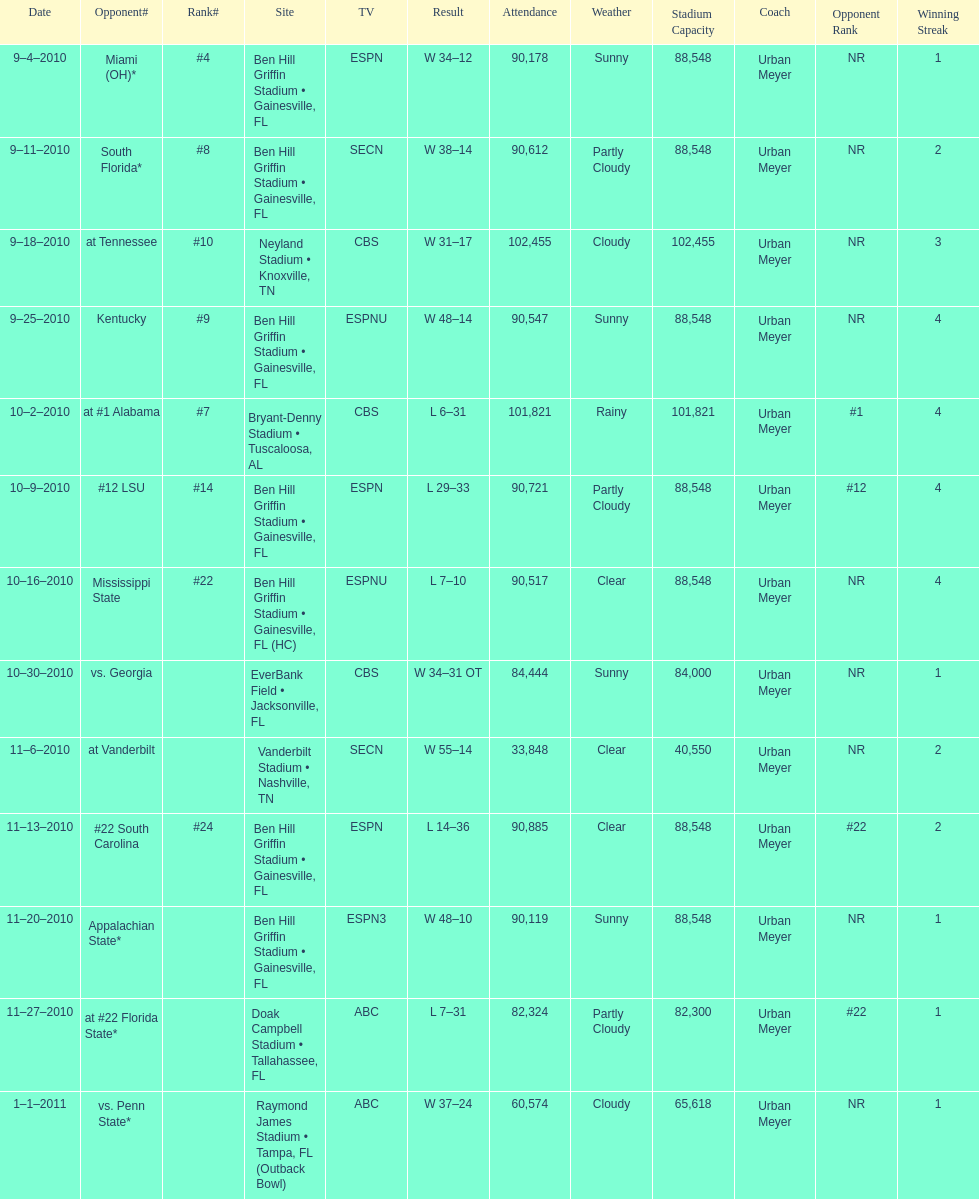What was the most the university of florida won by? 41 points. 